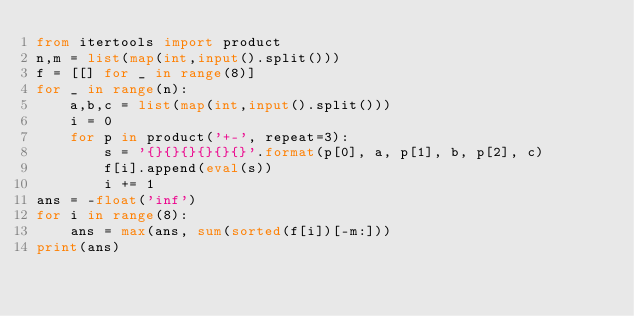<code> <loc_0><loc_0><loc_500><loc_500><_Python_>from itertools import product
n,m = list(map(int,input().split()))
f = [[] for _ in range(8)]
for _ in range(n):
    a,b,c = list(map(int,input().split()))
    i = 0
    for p in product('+-', repeat=3):
        s = '{}{}{}{}{}{}'.format(p[0], a, p[1], b, p[2], c)
        f[i].append(eval(s))
        i += 1
ans = -float('inf')
for i in range(8):
    ans = max(ans, sum(sorted(f[i])[-m:]))
print(ans)
</code> 